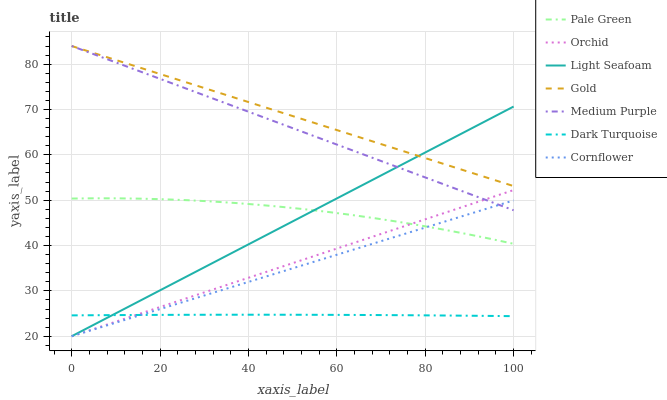Does Dark Turquoise have the minimum area under the curve?
Answer yes or no. Yes. Does Gold have the maximum area under the curve?
Answer yes or no. Yes. Does Gold have the minimum area under the curve?
Answer yes or no. No. Does Dark Turquoise have the maximum area under the curve?
Answer yes or no. No. Is Cornflower the smoothest?
Answer yes or no. Yes. Is Pale Green the roughest?
Answer yes or no. Yes. Is Gold the smoothest?
Answer yes or no. No. Is Gold the roughest?
Answer yes or no. No. Does Cornflower have the lowest value?
Answer yes or no. Yes. Does Dark Turquoise have the lowest value?
Answer yes or no. No. Does Medium Purple have the highest value?
Answer yes or no. Yes. Does Dark Turquoise have the highest value?
Answer yes or no. No. Is Pale Green less than Medium Purple?
Answer yes or no. Yes. Is Medium Purple greater than Dark Turquoise?
Answer yes or no. Yes. Does Light Seafoam intersect Medium Purple?
Answer yes or no. Yes. Is Light Seafoam less than Medium Purple?
Answer yes or no. No. Is Light Seafoam greater than Medium Purple?
Answer yes or no. No. Does Pale Green intersect Medium Purple?
Answer yes or no. No. 